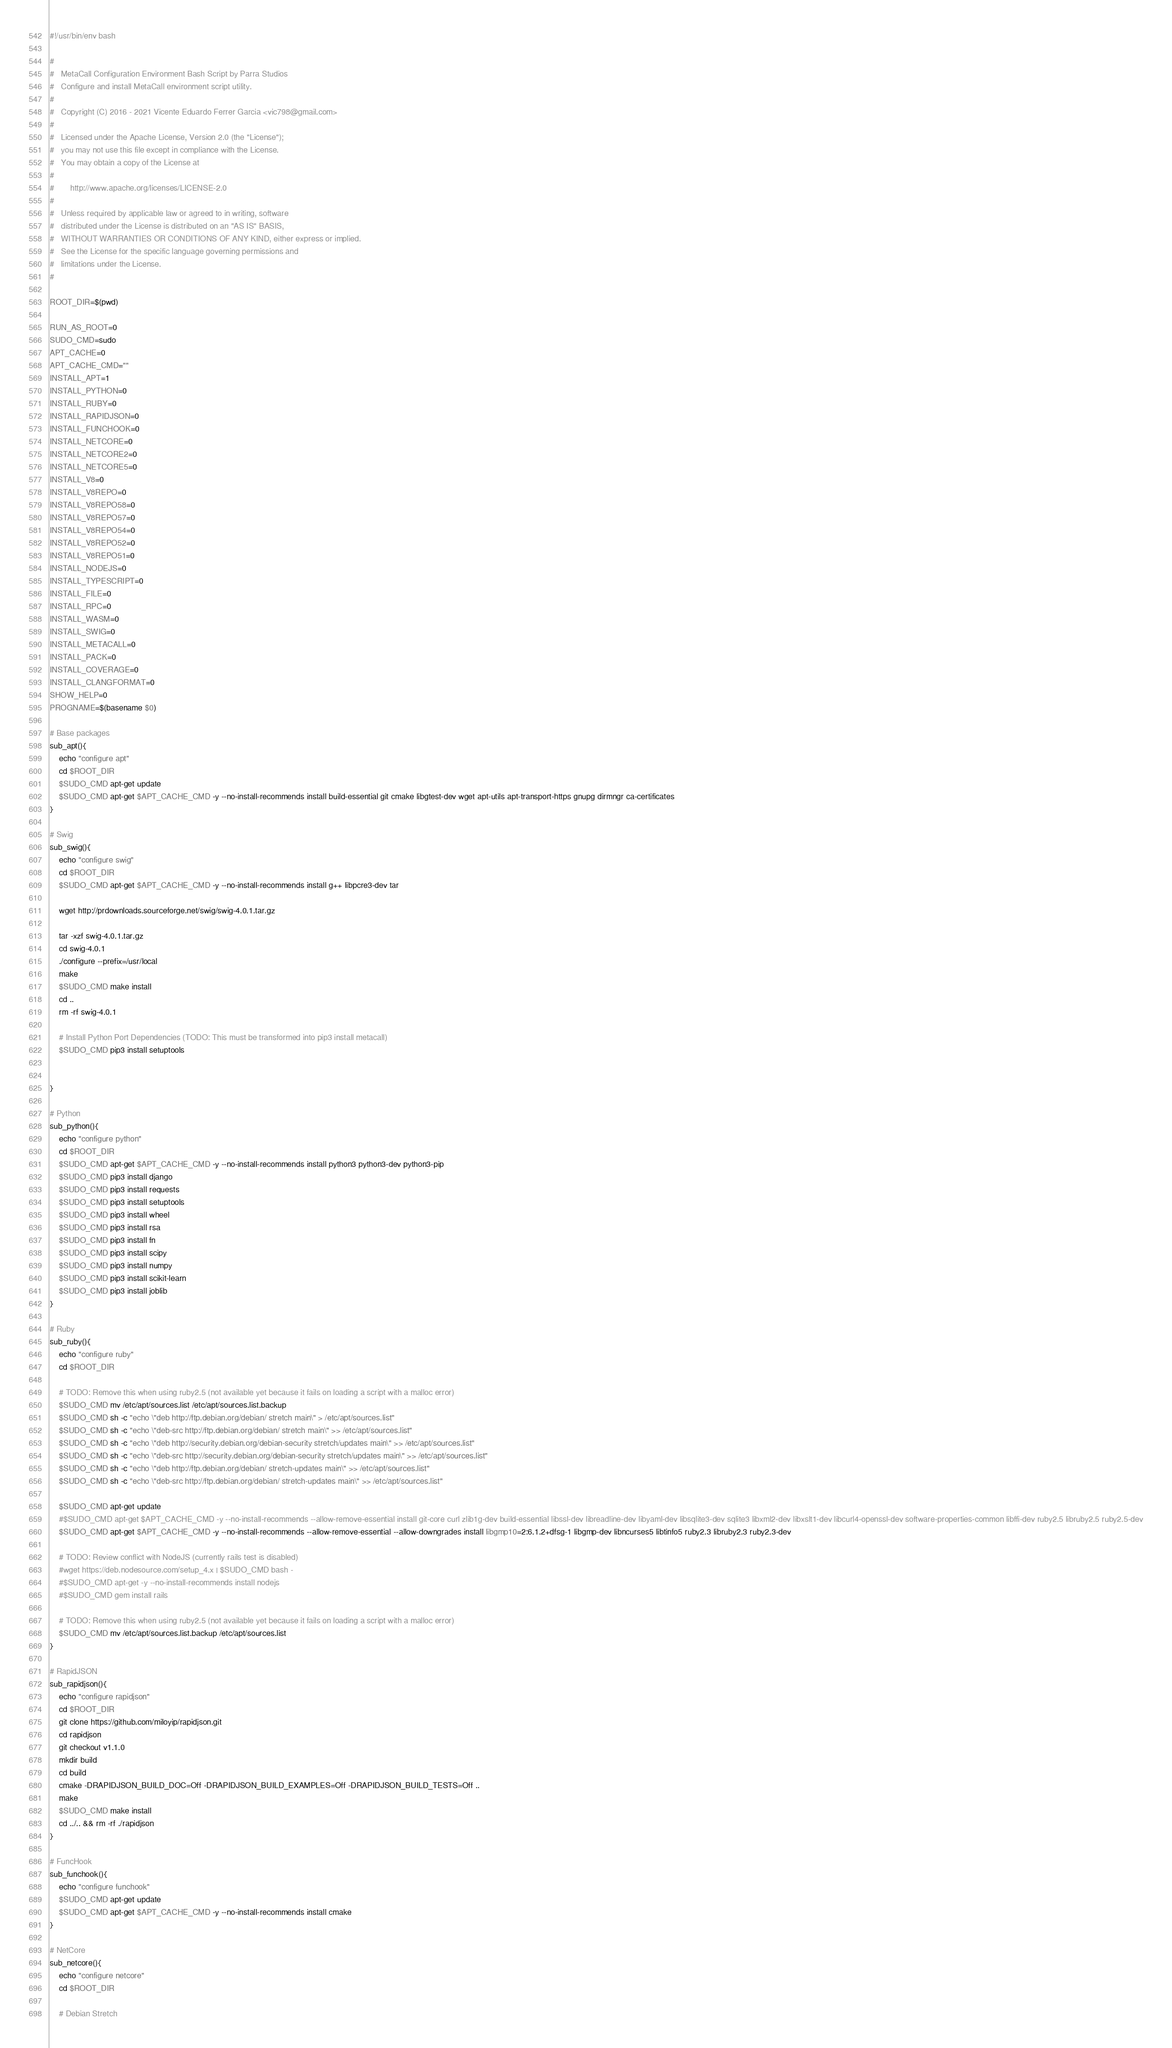Convert code to text. <code><loc_0><loc_0><loc_500><loc_500><_Bash_>#!/usr/bin/env bash

#
#	MetaCall Configuration Environment Bash Script by Parra Studios
#	Configure and install MetaCall environment script utility.
#
#	Copyright (C) 2016 - 2021 Vicente Eduardo Ferrer Garcia <vic798@gmail.com>
#
#	Licensed under the Apache License, Version 2.0 (the "License");
#	you may not use this file except in compliance with the License.
#	You may obtain a copy of the License at
#
#		http://www.apache.org/licenses/LICENSE-2.0
#
#	Unless required by applicable law or agreed to in writing, software
#	distributed under the License is distributed on an "AS IS" BASIS,
#	WITHOUT WARRANTIES OR CONDITIONS OF ANY KIND, either express or implied.
#	See the License for the specific language governing permissions and
#	limitations under the License.
#

ROOT_DIR=$(pwd)

RUN_AS_ROOT=0
SUDO_CMD=sudo
APT_CACHE=0
APT_CACHE_CMD=""
INSTALL_APT=1
INSTALL_PYTHON=0
INSTALL_RUBY=0
INSTALL_RAPIDJSON=0
INSTALL_FUNCHOOK=0
INSTALL_NETCORE=0
INSTALL_NETCORE2=0
INSTALL_NETCORE5=0
INSTALL_V8=0
INSTALL_V8REPO=0
INSTALL_V8REPO58=0
INSTALL_V8REPO57=0
INSTALL_V8REPO54=0
INSTALL_V8REPO52=0
INSTALL_V8REPO51=0
INSTALL_NODEJS=0
INSTALL_TYPESCRIPT=0
INSTALL_FILE=0
INSTALL_RPC=0
INSTALL_WASM=0
INSTALL_SWIG=0
INSTALL_METACALL=0
INSTALL_PACK=0
INSTALL_COVERAGE=0
INSTALL_CLANGFORMAT=0
SHOW_HELP=0
PROGNAME=$(basename $0)

# Base packages
sub_apt(){
	echo "configure apt"
	cd $ROOT_DIR
	$SUDO_CMD apt-get update
	$SUDO_CMD apt-get $APT_CACHE_CMD -y --no-install-recommends install build-essential git cmake libgtest-dev wget apt-utils apt-transport-https gnupg dirmngr ca-certificates
}

# Swig
sub_swig(){
	echo "configure swig"
	cd $ROOT_DIR
	$SUDO_CMD apt-get $APT_CACHE_CMD -y --no-install-recommends install g++ libpcre3-dev tar

	wget http://prdownloads.sourceforge.net/swig/swig-4.0.1.tar.gz

	tar -xzf swig-4.0.1.tar.gz
	cd swig-4.0.1
	./configure --prefix=/usr/local
	make
	$SUDO_CMD make install
	cd ..
	rm -rf swig-4.0.1

	# Install Python Port Dependencies (TODO: This must be transformed into pip3 install metacall)
	$SUDO_CMD pip3 install setuptools


}

# Python
sub_python(){
	echo "configure python"
	cd $ROOT_DIR
	$SUDO_CMD apt-get $APT_CACHE_CMD -y --no-install-recommends install python3 python3-dev python3-pip
	$SUDO_CMD pip3 install django
	$SUDO_CMD pip3 install requests
	$SUDO_CMD pip3 install setuptools
	$SUDO_CMD pip3 install wheel
	$SUDO_CMD pip3 install rsa
	$SUDO_CMD pip3 install fn
	$SUDO_CMD pip3 install scipy
	$SUDO_CMD pip3 install numpy
	$SUDO_CMD pip3 install scikit-learn
	$SUDO_CMD pip3 install joblib
}

# Ruby
sub_ruby(){
	echo "configure ruby"
	cd $ROOT_DIR

	# TODO: Remove this when using ruby2.5 (not available yet because it fails on loading a script with a malloc error)
	$SUDO_CMD mv /etc/apt/sources.list /etc/apt/sources.list.backup
	$SUDO_CMD sh -c "echo \"deb http://ftp.debian.org/debian/ stretch main\" > /etc/apt/sources.list"
	$SUDO_CMD sh -c "echo \"deb-src http://ftp.debian.org/debian/ stretch main\" >> /etc/apt/sources.list"
	$SUDO_CMD sh -c "echo \"deb http://security.debian.org/debian-security stretch/updates main\" >> /etc/apt/sources.list"
	$SUDO_CMD sh -c "echo \"deb-src http://security.debian.org/debian-security stretch/updates main\" >> /etc/apt/sources.list"
	$SUDO_CMD sh -c "echo \"deb http://ftp.debian.org/debian/ stretch-updates main\" >> /etc/apt/sources.list"
	$SUDO_CMD sh -c "echo \"deb-src http://ftp.debian.org/debian/ stretch-updates main\" >> /etc/apt/sources.list"

	$SUDO_CMD apt-get update
	#$SUDO_CMD apt-get $APT_CACHE_CMD -y --no-install-recommends --allow-remove-essential install git-core curl zlib1g-dev build-essential libssl-dev libreadline-dev libyaml-dev libsqlite3-dev sqlite3 libxml2-dev libxslt1-dev libcurl4-openssl-dev software-properties-common libffi-dev ruby2.5 libruby2.5 ruby2.5-dev
	$SUDO_CMD apt-get $APT_CACHE_CMD -y --no-install-recommends --allow-remove-essential --allow-downgrades install libgmp10=2:6.1.2+dfsg-1 libgmp-dev libncurses5 libtinfo5 ruby2.3 libruby2.3 ruby2.3-dev

	# TODO: Review conflict with NodeJS (currently rails test is disabled)
	#wget https://deb.nodesource.com/setup_4.x | $SUDO_CMD bash -
	#$SUDO_CMD apt-get -y --no-install-recommends install nodejs
	#$SUDO_CMD gem install rails

	# TODO: Remove this when using ruby2.5 (not available yet because it fails on loading a script with a malloc error)
	$SUDO_CMD mv /etc/apt/sources.list.backup /etc/apt/sources.list
}

# RapidJSON
sub_rapidjson(){
	echo "configure rapidjson"
	cd $ROOT_DIR
	git clone https://github.com/miloyip/rapidjson.git
	cd rapidjson
	git checkout v1.1.0
	mkdir build
	cd build
	cmake -DRAPIDJSON_BUILD_DOC=Off -DRAPIDJSON_BUILD_EXAMPLES=Off -DRAPIDJSON_BUILD_TESTS=Off ..
	make
	$SUDO_CMD make install
	cd ../.. && rm -rf ./rapidjson
}

# FuncHook
sub_funchook(){
	echo "configure funchook"
	$SUDO_CMD apt-get update
	$SUDO_CMD apt-get $APT_CACHE_CMD -y --no-install-recommends install cmake
}

# NetCore
sub_netcore(){
	echo "configure netcore"
	cd $ROOT_DIR

	# Debian Stretch
</code> 